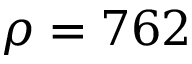Convert formula to latex. <formula><loc_0><loc_0><loc_500><loc_500>\rho = 7 6 2</formula> 